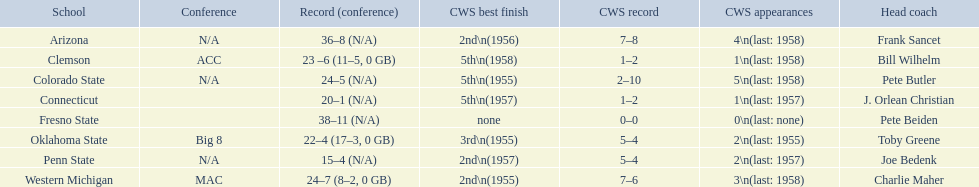What are all the schools? Arizona, Clemson, Colorado State, Connecticut, Fresno State, Oklahoma State, Penn State, Western Michigan. Which are clemson and western michigan? Clemson, Western Michigan. Of these, which has more cws appearances? Western Michigan. 